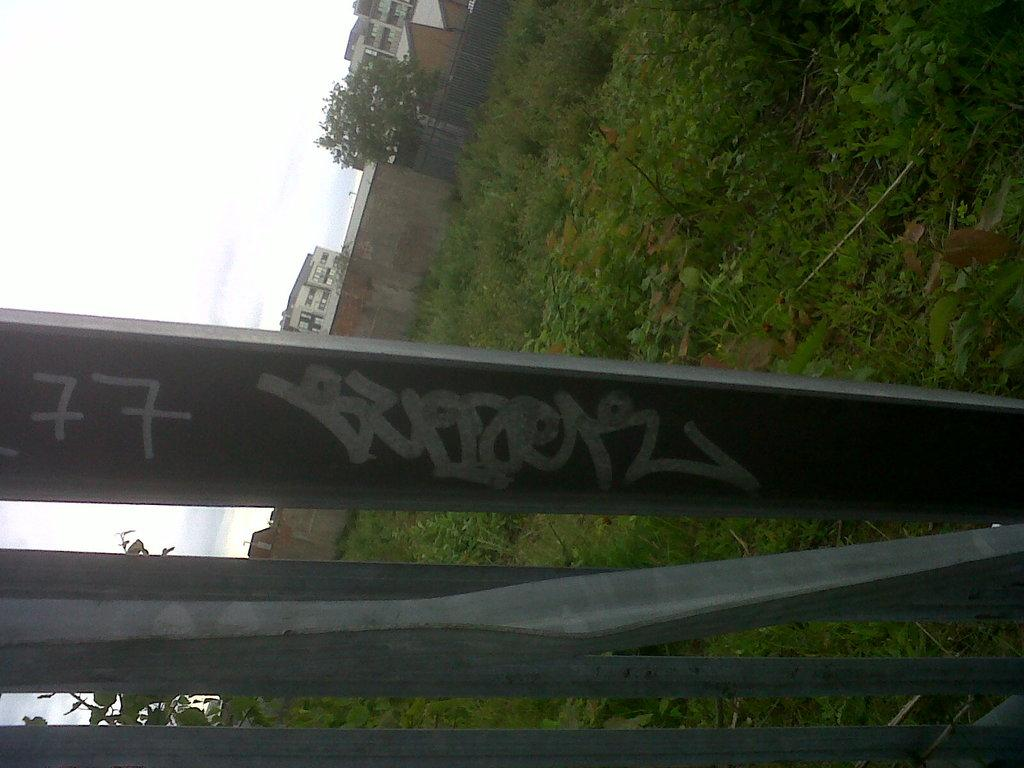What type of natural elements can be seen in the image? There are plants and trees in the image. What type of man-made structures are present in the image? There are buildings in the image. What type of material is used for the rods in the image? The rods in the image are made of metal. What is the weather like in the image? The sky is cloudy in the image. Who is the minister in the image? There is no minister present in the image. What type of competition is taking place in the image? There is no competition present in the image. 